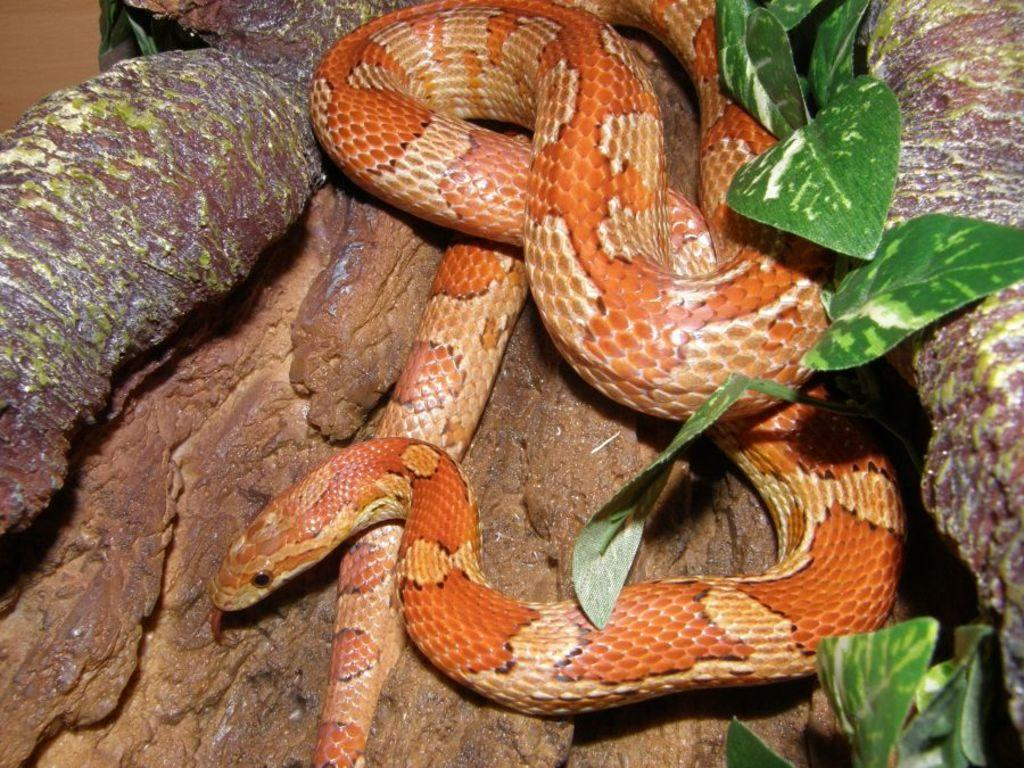What type of animal is in the image? There is a snake in the image. What colors can be seen on the snake? The snake has cream and brown colors. What is the snake resting on in the image? The snake is on a wooden object. What can be seen to the right of the image? There are leaves visible to the right of the image. What type of rhythm does the snake create while walking in the image? The snake is not walking in the image, and therefore does not create any rhythm. Can you see any flames in the image? There are no flames present in the image. 